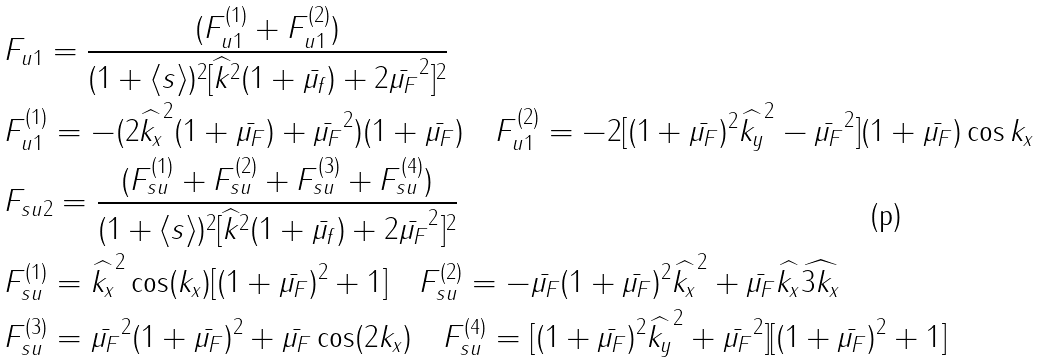<formula> <loc_0><loc_0><loc_500><loc_500>& F _ { u 1 } = \frac { ( F ^ { ( 1 ) } _ { u 1 } + F ^ { ( 2 ) } _ { u 1 } ) } { ( 1 + \langle s \rangle ) ^ { 2 } [ \widehat { k } ^ { 2 } ( 1 + \bar { \mu _ { f } } ) + 2 \bar { \mu _ { F } } ^ { 2 } ] ^ { 2 } } \\ & F ^ { ( 1 ) } _ { u 1 } = - ( 2 \widehat { k _ { x } } ^ { 2 } ( 1 + \bar { \mu _ { F } } ) + \bar { \mu _ { F } } ^ { 2 } ) ( 1 + \bar { \mu _ { F } } ) \quad F ^ { ( 2 ) } _ { u 1 } = - 2 [ ( 1 + \bar { \mu _ { F } } ) ^ { 2 } \widehat { k _ { y } } ^ { 2 } - \bar { \mu _ { F } } ^ { 2 } ] ( 1 + \bar { \mu _ { F } } ) \cos k _ { x } \\ & F _ { s u 2 } = \frac { ( F ^ { ( 1 ) } _ { s u } + F ^ { ( 2 ) } _ { s u } + F ^ { ( 3 ) } _ { s u } + F ^ { ( 4 ) } _ { s u } ) } { ( 1 + \langle s \rangle ) ^ { 2 } [ \widehat { k } ^ { 2 } ( 1 + \bar { \mu _ { f } } ) + 2 \bar { \mu _ { F } } ^ { 2 } ] ^ { 2 } } \\ & F ^ { ( 1 ) } _ { s u } = \widehat { k _ { x } } ^ { 2 } \cos ( k _ { x } ) [ ( 1 + \bar { \mu _ { F } } ) ^ { 2 } + 1 ] \quad F ^ { ( 2 ) } _ { s u } = - \bar { \mu _ { F } } ( 1 + \bar { \mu _ { F } } ) ^ { 2 } \widehat { k _ { x } } ^ { 2 } + \bar { \mu _ { F } } \widehat { k _ { x } } \widehat { 3 k _ { x } } \\ & F ^ { ( 3 ) } _ { s u } = \bar { \mu _ { F } } ^ { 2 } ( 1 + \bar { \mu _ { F } } ) ^ { 2 } + \bar { \mu _ { F } } \cos ( 2 k _ { x } ) \quad F ^ { ( 4 ) } _ { s u } = [ ( 1 + \bar { \mu _ { F } } ) ^ { 2 } \widehat { k _ { y } } ^ { 2 } + \bar { \mu _ { F } } ^ { 2 } ] [ ( 1 + \bar { \mu _ { F } } ) ^ { 2 } + 1 ]</formula> 